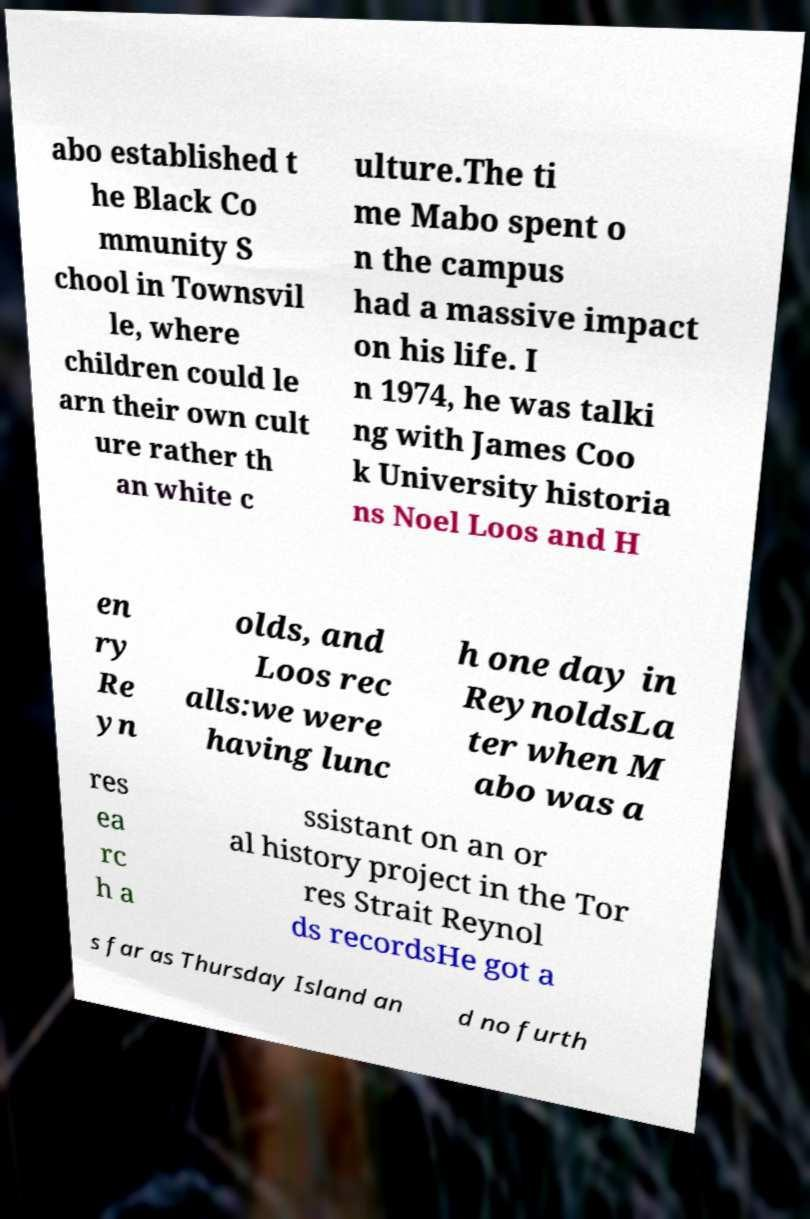Please identify and transcribe the text found in this image. abo established t he Black Co mmunity S chool in Townsvil le, where children could le arn their own cult ure rather th an white c ulture.The ti me Mabo spent o n the campus had a massive impact on his life. I n 1974, he was talki ng with James Coo k University historia ns Noel Loos and H en ry Re yn olds, and Loos rec alls:we were having lunc h one day in ReynoldsLa ter when M abo was a res ea rc h a ssistant on an or al history project in the Tor res Strait Reynol ds recordsHe got a s far as Thursday Island an d no furth 